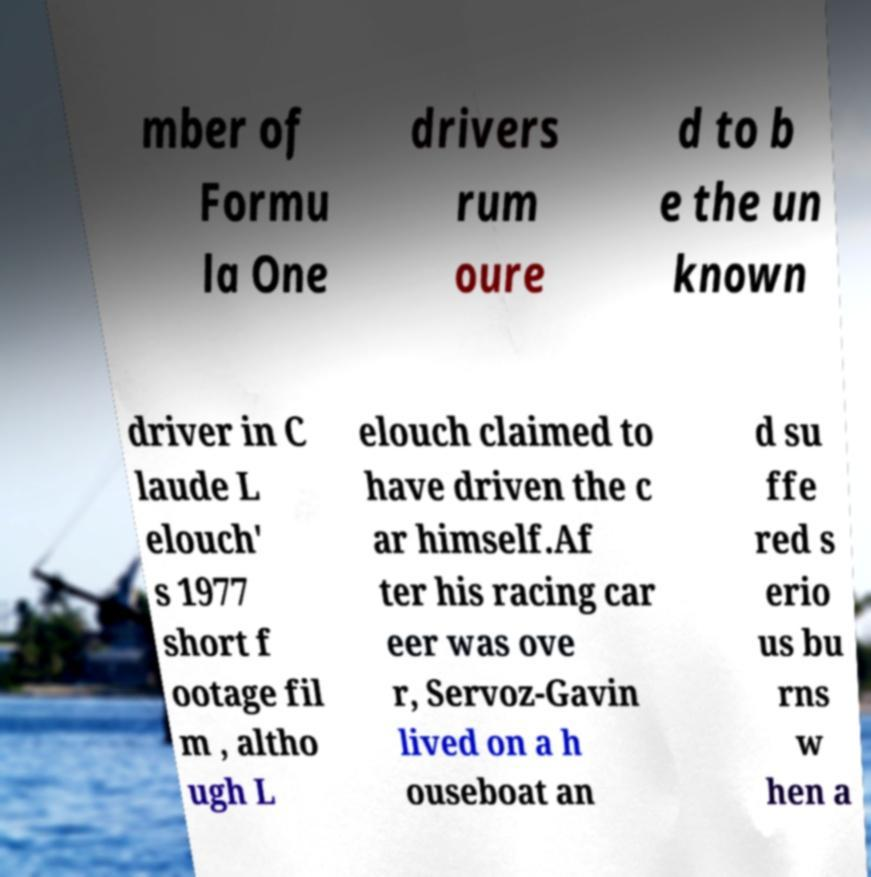Please read and relay the text visible in this image. What does it say? mber of Formu la One drivers rum oure d to b e the un known driver in C laude L elouch' s 1977 short f ootage fil m , altho ugh L elouch claimed to have driven the c ar himself.Af ter his racing car eer was ove r, Servoz-Gavin lived on a h ouseboat an d su ffe red s erio us bu rns w hen a 